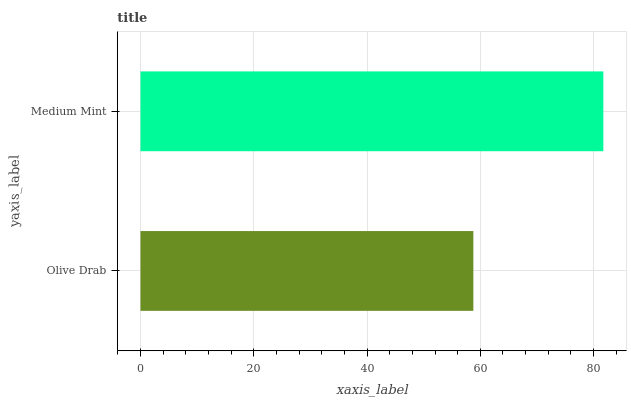Is Olive Drab the minimum?
Answer yes or no. Yes. Is Medium Mint the maximum?
Answer yes or no. Yes. Is Medium Mint the minimum?
Answer yes or no. No. Is Medium Mint greater than Olive Drab?
Answer yes or no. Yes. Is Olive Drab less than Medium Mint?
Answer yes or no. Yes. Is Olive Drab greater than Medium Mint?
Answer yes or no. No. Is Medium Mint less than Olive Drab?
Answer yes or no. No. Is Medium Mint the high median?
Answer yes or no. Yes. Is Olive Drab the low median?
Answer yes or no. Yes. Is Olive Drab the high median?
Answer yes or no. No. Is Medium Mint the low median?
Answer yes or no. No. 